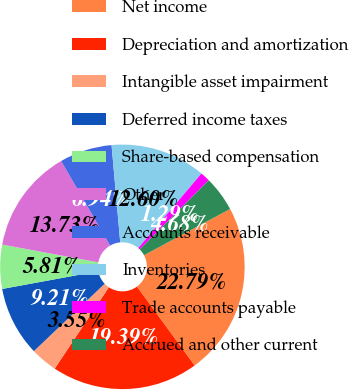Convert chart. <chart><loc_0><loc_0><loc_500><loc_500><pie_chart><fcel>Net income<fcel>Depreciation and amortization<fcel>Intangible asset impairment<fcel>Deferred income taxes<fcel>Share-based compensation<fcel>Other<fcel>Accounts receivable<fcel>Inventories<fcel>Trade accounts payable<fcel>Accrued and other current<nl><fcel>22.79%<fcel>19.39%<fcel>3.55%<fcel>9.21%<fcel>5.81%<fcel>13.73%<fcel>6.94%<fcel>12.6%<fcel>1.29%<fcel>4.68%<nl></chart> 